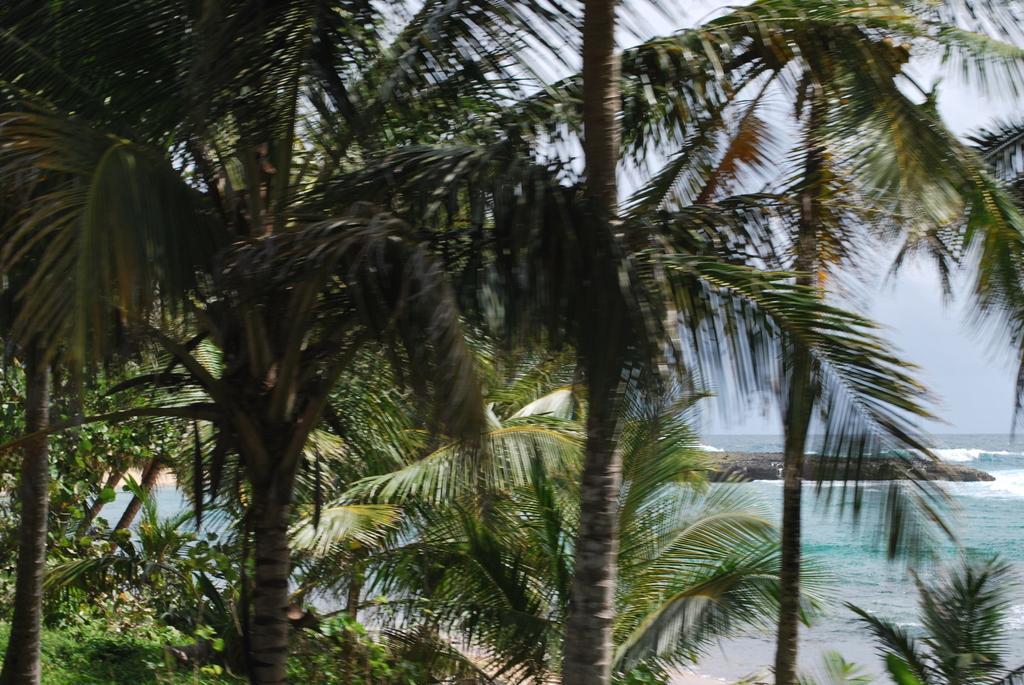Describe this image in one or two sentences. On the left side of the image there are huge trees. On the right side of the image there is a river. In the background there is a sky. 